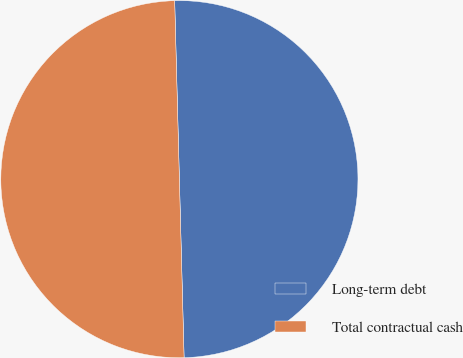<chart> <loc_0><loc_0><loc_500><loc_500><pie_chart><fcel>Long-term debt<fcel>Total contractual cash<nl><fcel>50.0%<fcel>50.0%<nl></chart> 